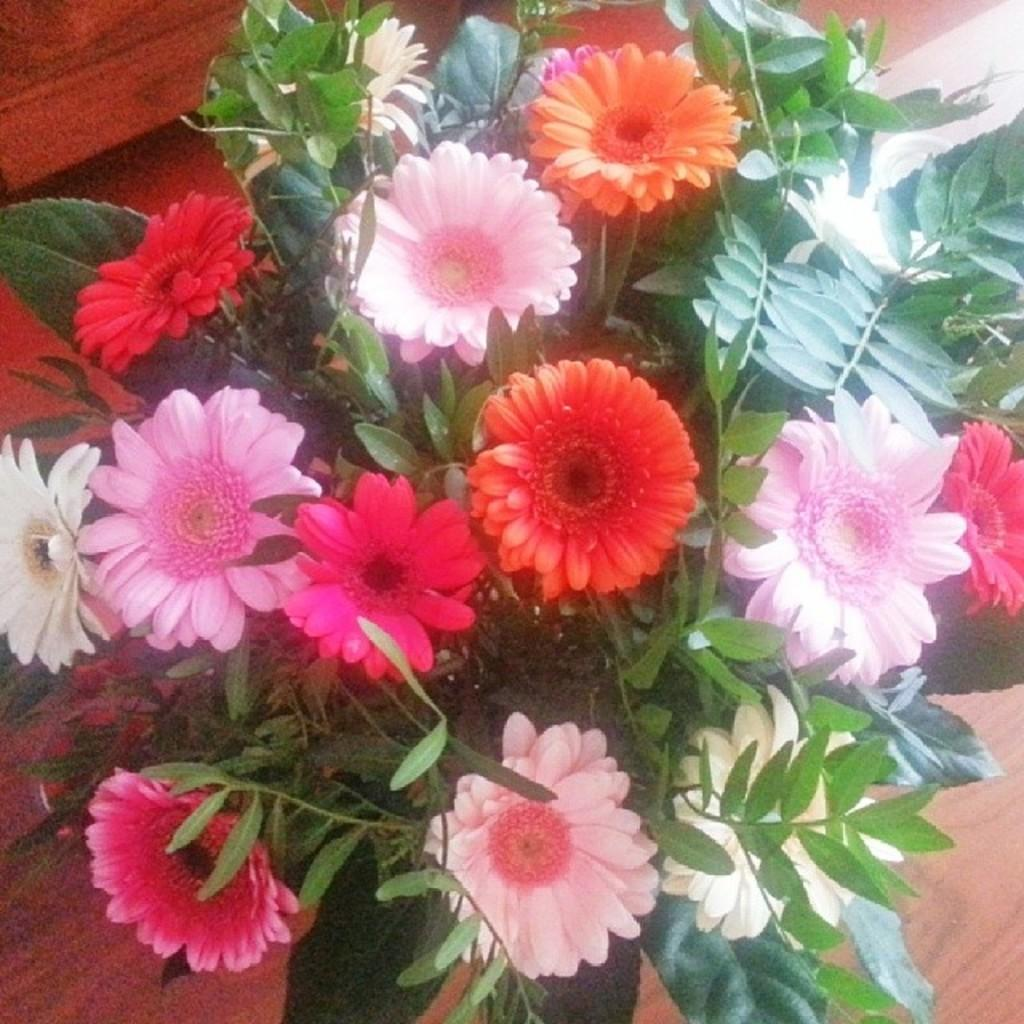What types of plants are present in the image? There are flowers of different colors in the image. What else can be seen in the image besides the flowers? There are leaves visible in the image. What material is the surface that the flowers and leaves are on? There is a wooden surface in the image. What decisions has the committee made regarding the window in the image? There is no committee or window present in the image; it features flowers and leaves on a wooden surface. 